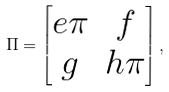Convert formula to latex. <formula><loc_0><loc_0><loc_500><loc_500>\Pi = \begin{bmatrix} e \pi & f \\ g & h \pi \end{bmatrix} ,</formula> 